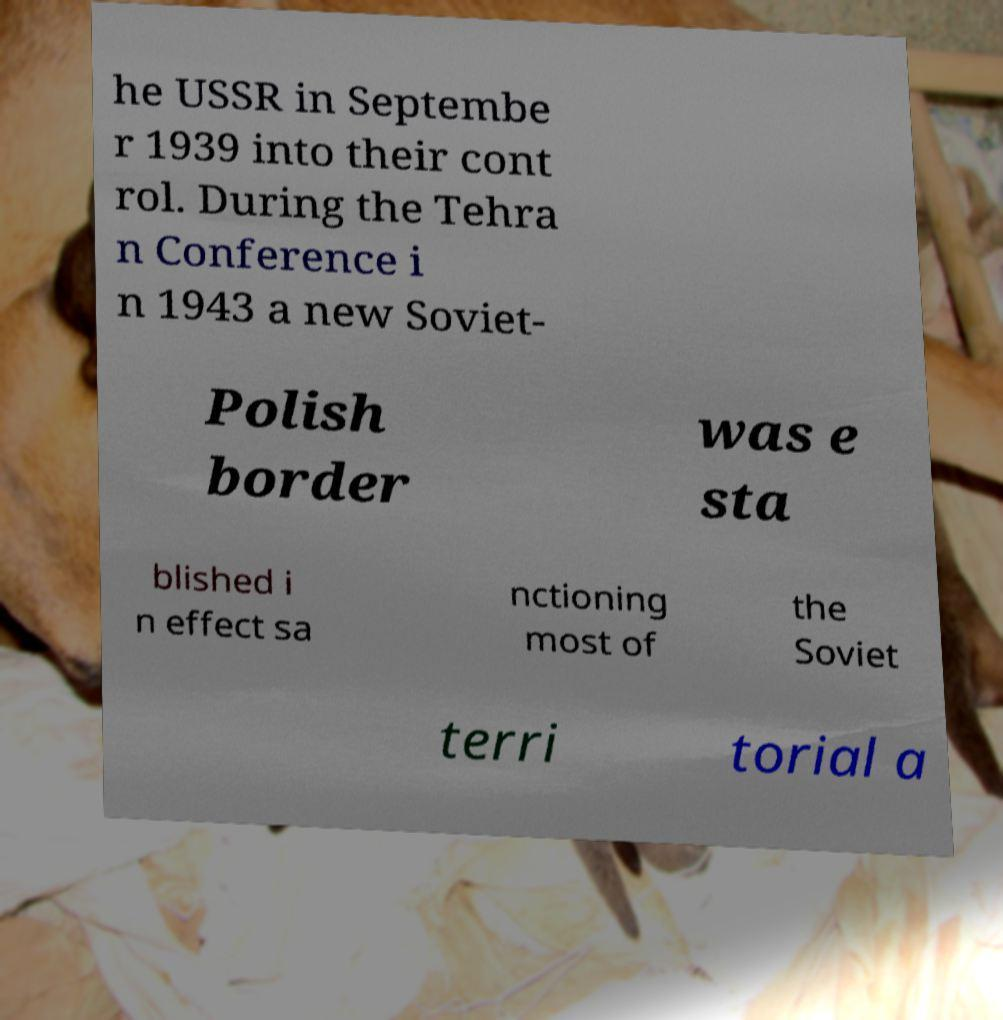Could you assist in decoding the text presented in this image and type it out clearly? he USSR in Septembe r 1939 into their cont rol. During the Tehra n Conference i n 1943 a new Soviet- Polish border was e sta blished i n effect sa nctioning most of the Soviet terri torial a 